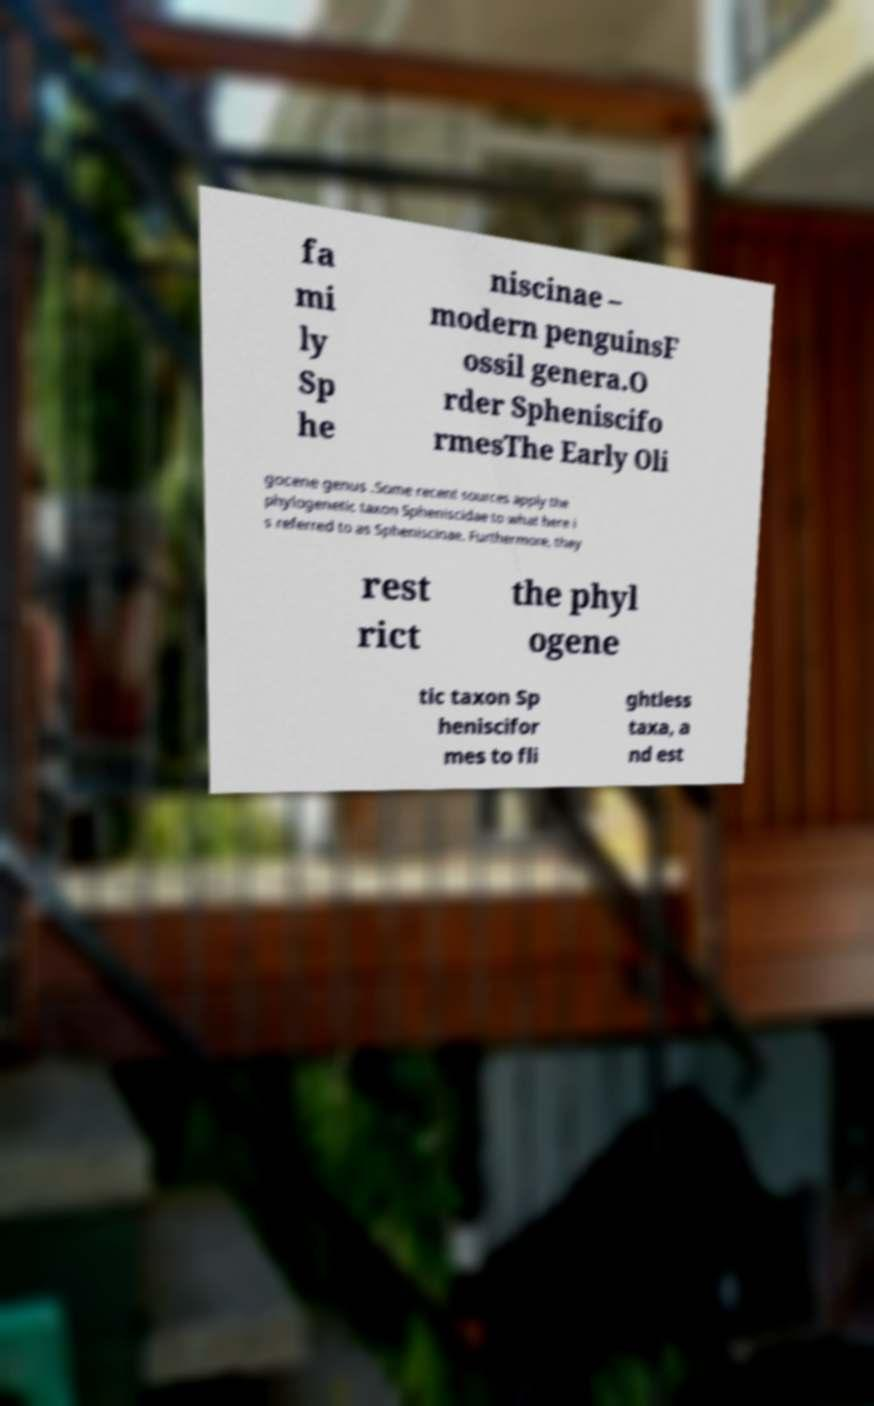Can you accurately transcribe the text from the provided image for me? fa mi ly Sp he niscinae – modern penguinsF ossil genera.O rder Spheniscifo rmesThe Early Oli gocene genus .Some recent sources apply the phylogenetic taxon Spheniscidae to what here i s referred to as Spheniscinae. Furthermore, they rest rict the phyl ogene tic taxon Sp heniscifor mes to fli ghtless taxa, a nd est 